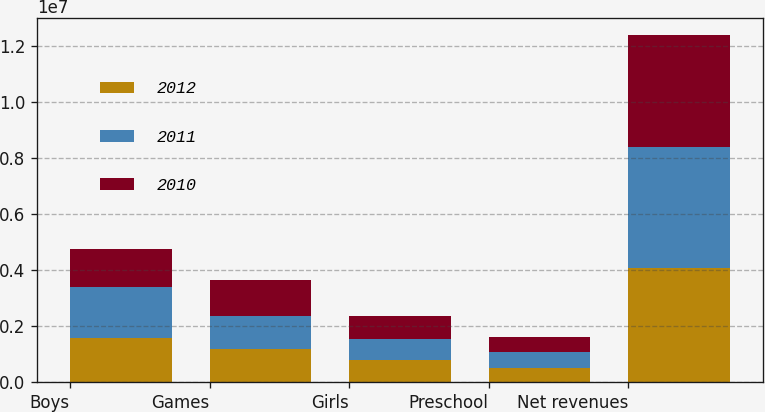<chart> <loc_0><loc_0><loc_500><loc_500><stacked_bar_chart><ecel><fcel>Boys<fcel>Games<fcel>Girls<fcel>Preschool<fcel>Net revenues<nl><fcel>2012<fcel>1.57701e+06<fcel>1.19209e+06<fcel>792292<fcel>527591<fcel>4.08898e+06<nl><fcel>2011<fcel>1.82154e+06<fcel>1.16967e+06<fcel>741394<fcel>552979<fcel>4.28559e+06<nl><fcel>2010<fcel>1.34552e+06<fcel>1.29377e+06<fcel>830383<fcel>532483<fcel>4.00216e+06<nl></chart> 